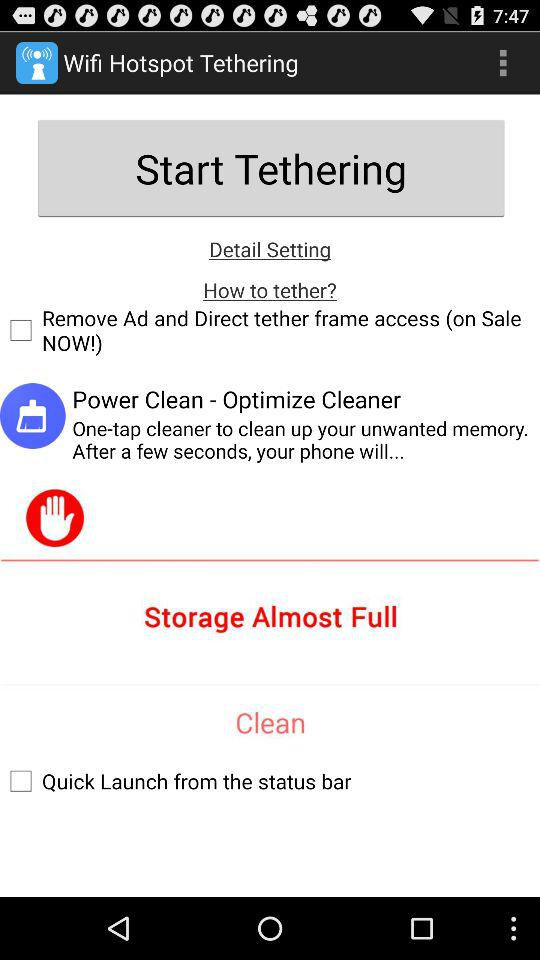What is the status of "Remove Ad and Direct tether frame access"? The status is "off". 